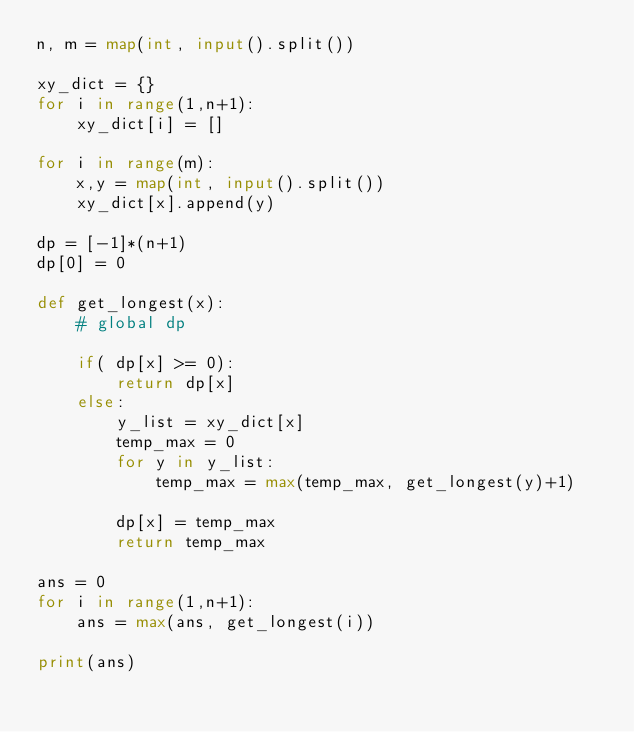<code> <loc_0><loc_0><loc_500><loc_500><_Python_>n, m = map(int, input().split())

xy_dict = {}
for i in range(1,n+1):
    xy_dict[i] = []

for i in range(m):
    x,y = map(int, input().split())
    xy_dict[x].append(y)

dp = [-1]*(n+1)
dp[0] = 0

def get_longest(x):
    # global dp

    if( dp[x] >= 0):
        return dp[x]
    else:
        y_list = xy_dict[x]
        temp_max = 0
        for y in y_list:
            temp_max = max(temp_max, get_longest(y)+1)

        dp[x] = temp_max
        return temp_max

ans = 0
for i in range(1,n+1):
    ans = max(ans, get_longest(i))

print(ans)</code> 